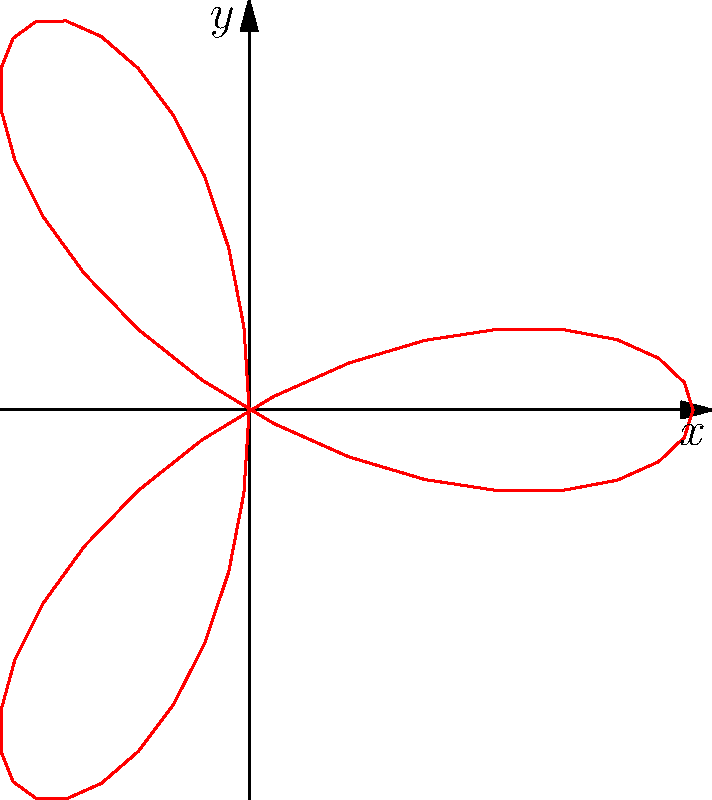Doug Frost claims that the area enclosed by the polar rose $r = \cos(3\theta)$ is $\frac{\pi}{2}$. As his skeptical former colleague, you decide to verify this claim. Calculate the exact area enclosed by this polar rose and determine if Doug's assertion is correct. Let's approach this step-by-step:

1) The general formula for the area enclosed by a polar curve is:
   $$A = \frac{1}{2} \int_{0}^{2\pi} r^2(\theta) d\theta$$

2) In this case, $r(\theta) = \cos(3\theta)$, so we need to calculate:
   $$A = \frac{1}{2} \int_{0}^{2\pi} \cos^2(3\theta) d\theta$$

3) We can use the trigonometric identity: $\cos^2(x) = \frac{1 + \cos(2x)}{2}$
   $$A = \frac{1}{2} \int_{0}^{2\pi} \frac{1 + \cos(6\theta)}{2} d\theta$$

4) Simplifying:
   $$A = \frac{1}{4} \int_{0}^{2\pi} (1 + \cos(6\theta)) d\theta$$

5) Integrating:
   $$A = \frac{1}{4} [\theta + \frac{1}{6}\sin(6\theta)]_{0}^{2\pi}$$

6) Evaluating the limits:
   $$A = \frac{1}{4} [(2\pi + 0) - (0 + 0)] = \frac{2\pi}{4} = \frac{\pi}{2}$$

Therefore, the exact area enclosed by the polar rose $r = \cos(3\theta)$ is indeed $\frac{\pi}{2}$, confirming Doug Frost's claim.
Answer: $\frac{\pi}{2}$ 